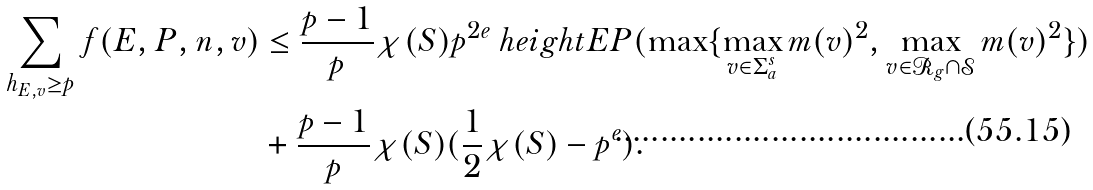Convert formula to latex. <formula><loc_0><loc_0><loc_500><loc_500>\sum _ { h _ { E , v } \geq p } f ( E , P , n , v ) & \leq \frac { p - 1 } { p } \chi ( S ) p ^ { 2 e } \ h e i g h t E { P } ( \max \{ \max _ { v \in \Sigma _ { a } ^ { s } } m ( v ) ^ { 2 } , \max _ { v \in \mathcal { R } _ { g } \cap \mathcal { S } } m ( v ) ^ { 2 } \} ) \\ & + \frac { p - 1 } { p } \chi ( S ) ( \frac { 1 } { 2 } \chi ( S ) - p ^ { e } ) .</formula> 